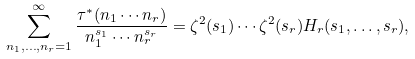Convert formula to latex. <formula><loc_0><loc_0><loc_500><loc_500>\sum _ { n _ { 1 } , \dots , n _ { r } = 1 } ^ { \infty } \frac { \tau ^ { * } ( n _ { 1 } \cdots n _ { r } ) } { n _ { 1 } ^ { s _ { 1 } } \cdots n _ { r } ^ { s _ { r } } } = \zeta ^ { 2 } ( s _ { 1 } ) \cdots \zeta ^ { 2 } ( s _ { r } ) H _ { r } ( s _ { 1 } , \dots , s _ { r } ) ,</formula> 